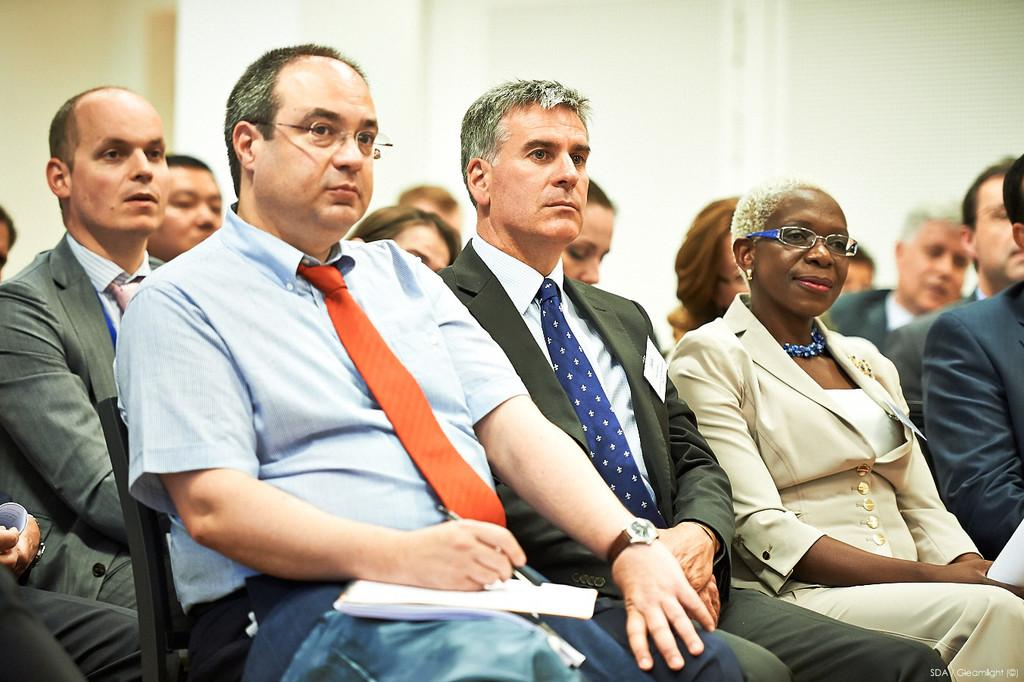What is happening in the image? There is a group of people in the image, and they are sitting on chairs. Can you describe the man in the image? The man is holding papers and a pen. What can be seen in the background of the image? There is a wall in the background of the image. What type of powder is being used by the people in the image? There is no powder present in the image; the people are sitting on chairs and the man is holding papers and a pen. 